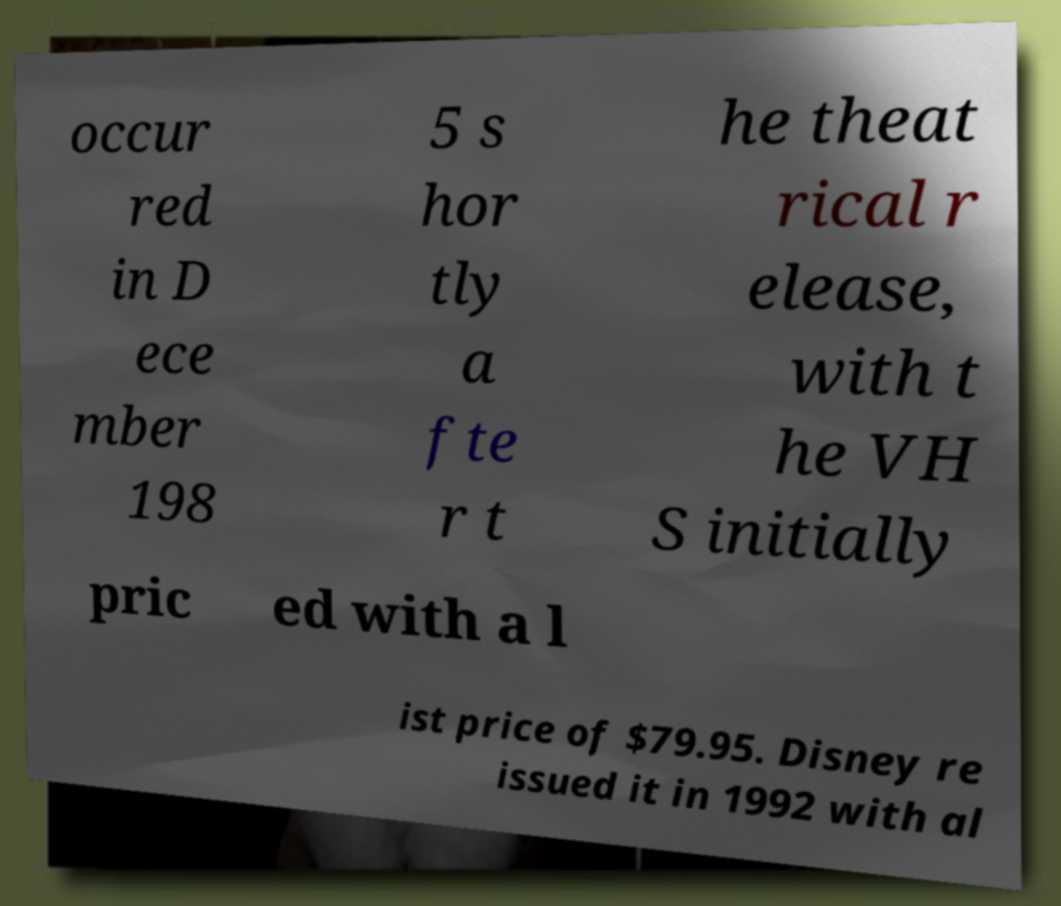For documentation purposes, I need the text within this image transcribed. Could you provide that? occur red in D ece mber 198 5 s hor tly a fte r t he theat rical r elease, with t he VH S initially pric ed with a l ist price of $79.95. Disney re issued it in 1992 with al 